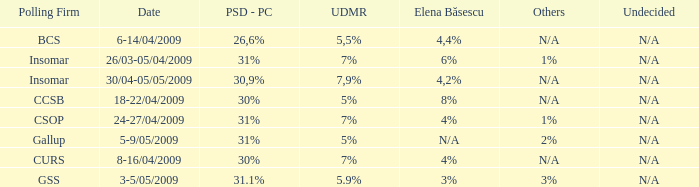What is the psd-pc for 18-22/04/2009? 30%. 